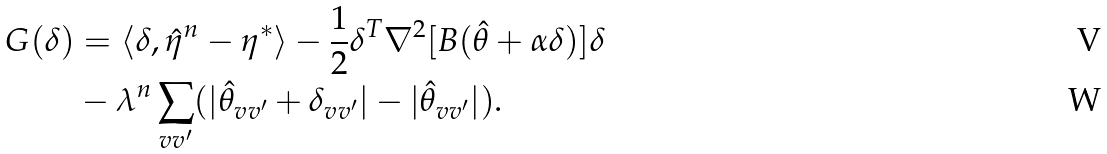Convert formula to latex. <formula><loc_0><loc_0><loc_500><loc_500>G ( \delta ) & = \langle \delta , \hat { \eta } ^ { n } - \eta ^ { * } \rangle - \frac { 1 } { 2 } \delta ^ { T } \nabla ^ { 2 } [ B ( \hat { \theta } + \alpha \delta ) ] \delta \\ & - \lambda ^ { n } \sum _ { v v ^ { \prime } } ( | \hat { \theta } _ { v v ^ { \prime } } + \delta _ { v v ^ { \prime } } | - | \hat { \theta } _ { v v ^ { \prime } } | ) .</formula> 